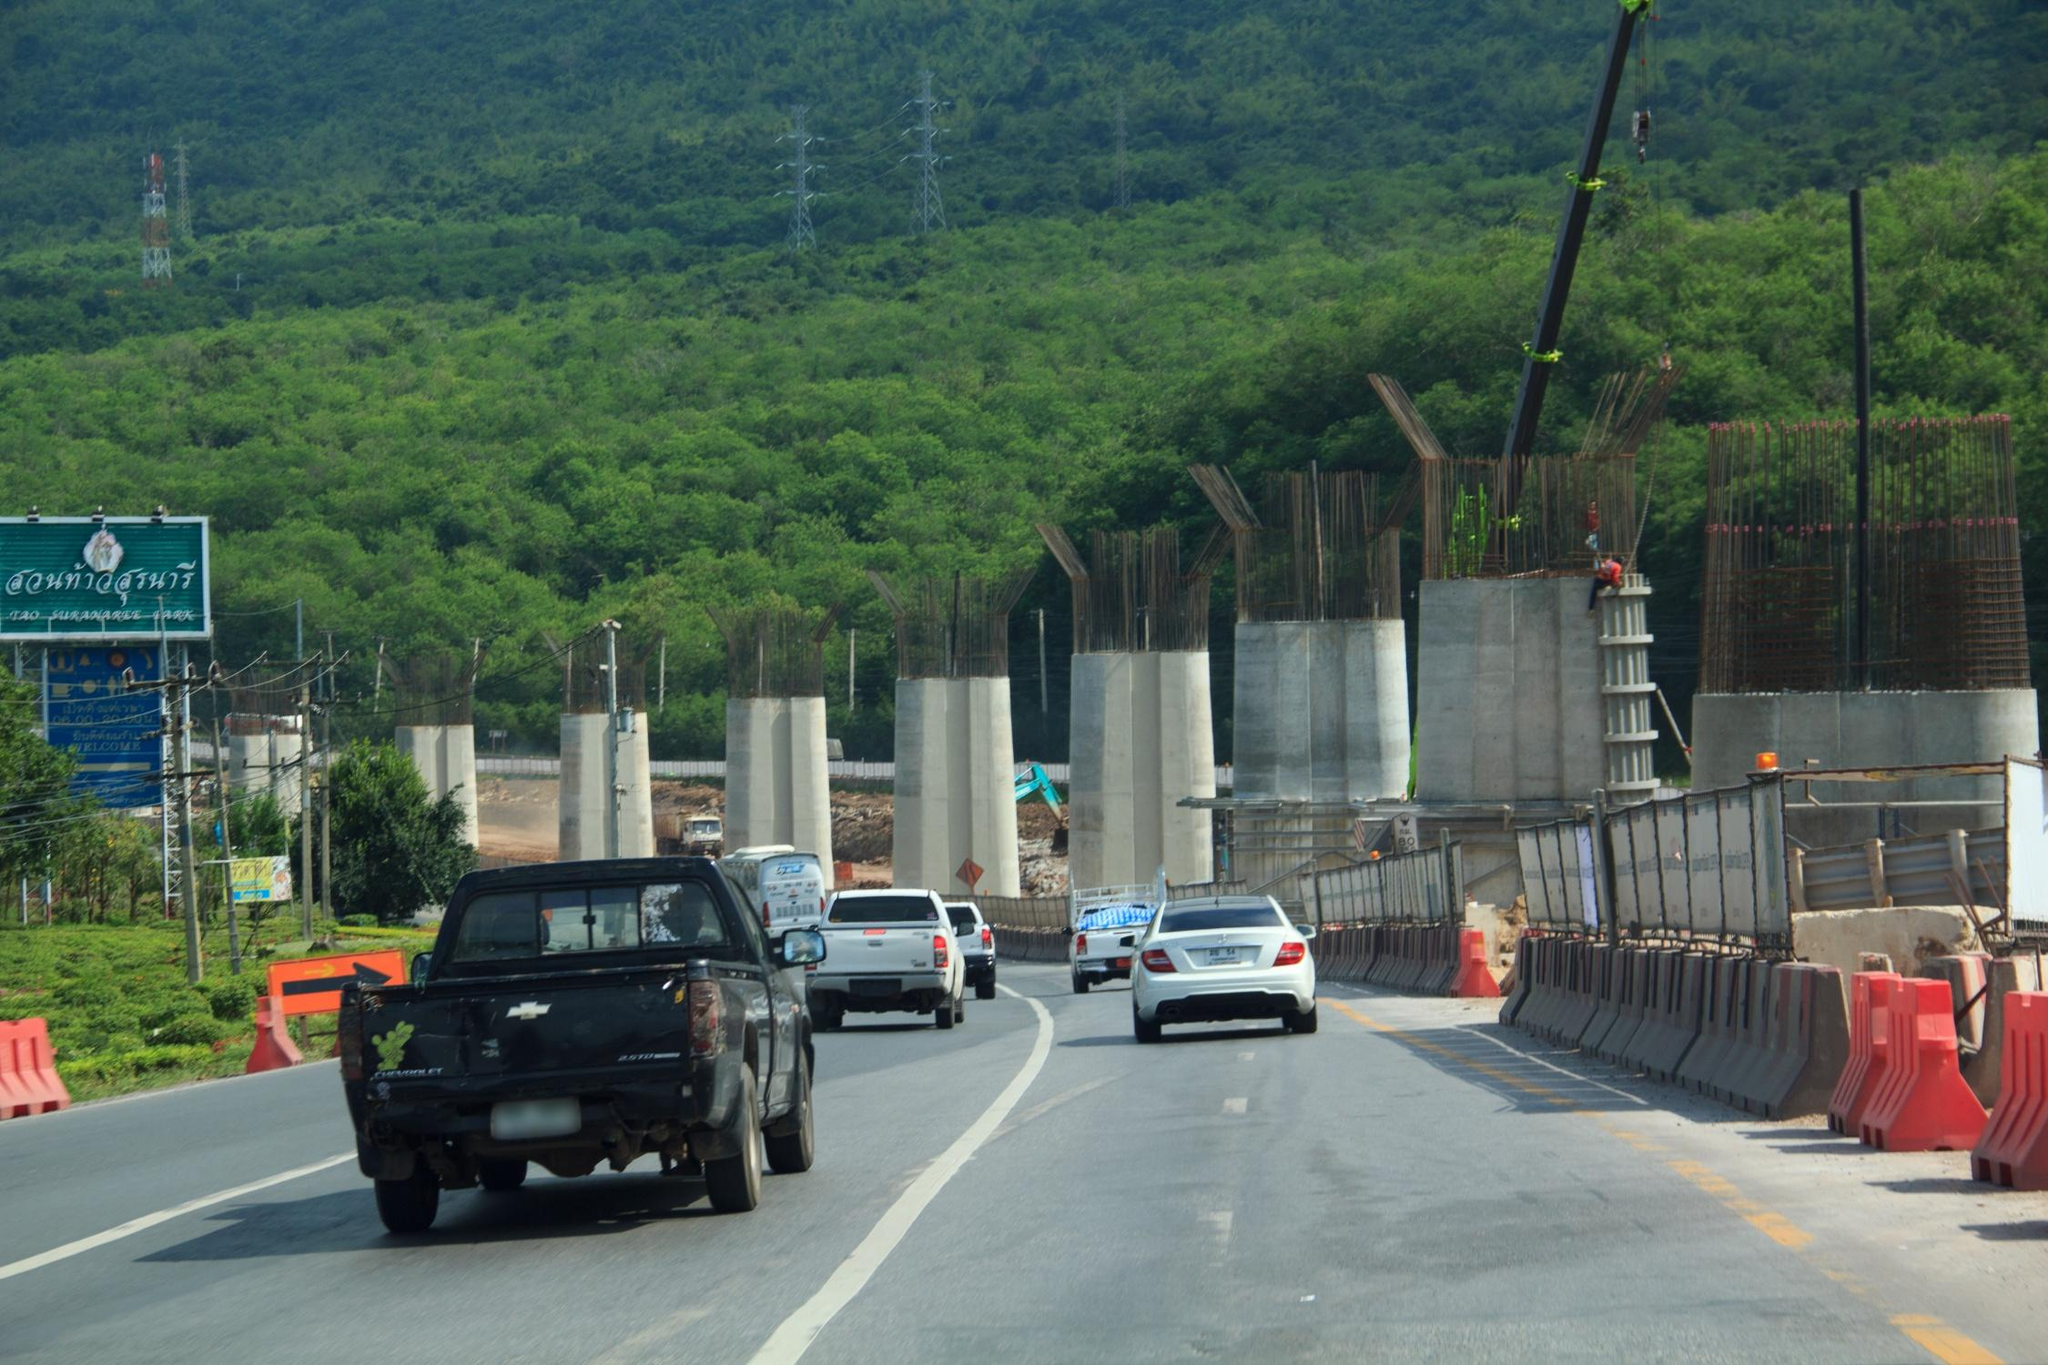Describe a realistic scenario of the image involving morning traffic. During the early morning rush hour, the scene presents a picture of bustling activity. As the sun rises over the verdant mountains, casting a golden hue on the landscape, a steady stream of vehicles begins to fill the highway. Construction workers, already on site, prepare for another day of progress. Commuters, driving a mix of personal cars and work trucks, cautiously navigate past the orange traffic barriers. The hum of engines and occasional honks outline the typical start to a day, with drivers anticipating reaching their workplaces on time despite the ongoing construction. This image captures a normal start to the day, balancing the routine of daily travel with the ongoing efforts to enhance future commutes. 